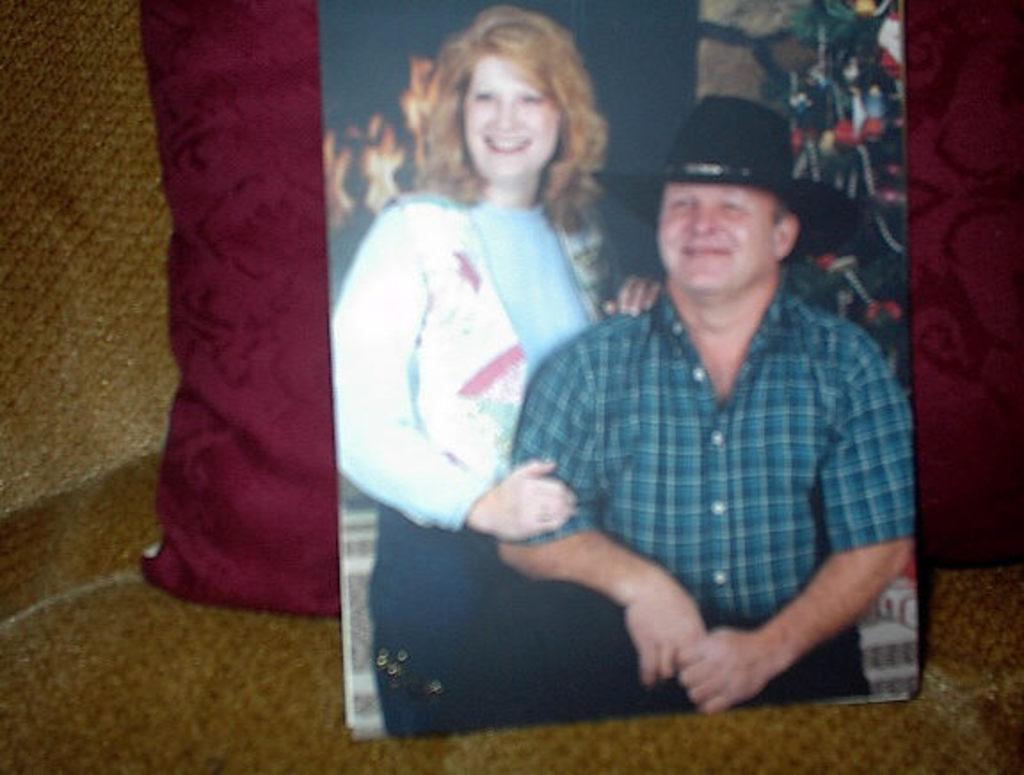What is the main subject of the image? There is a photograph in the image. What can be seen in the photograph? The photograph contains a man and a woman. What is the man wearing in the photograph? The man is wearing a cap. What type of sponge is being used to clean the doll in the image? There is no sponge or doll present in the image; it only contains a photograph with a man and a woman. 